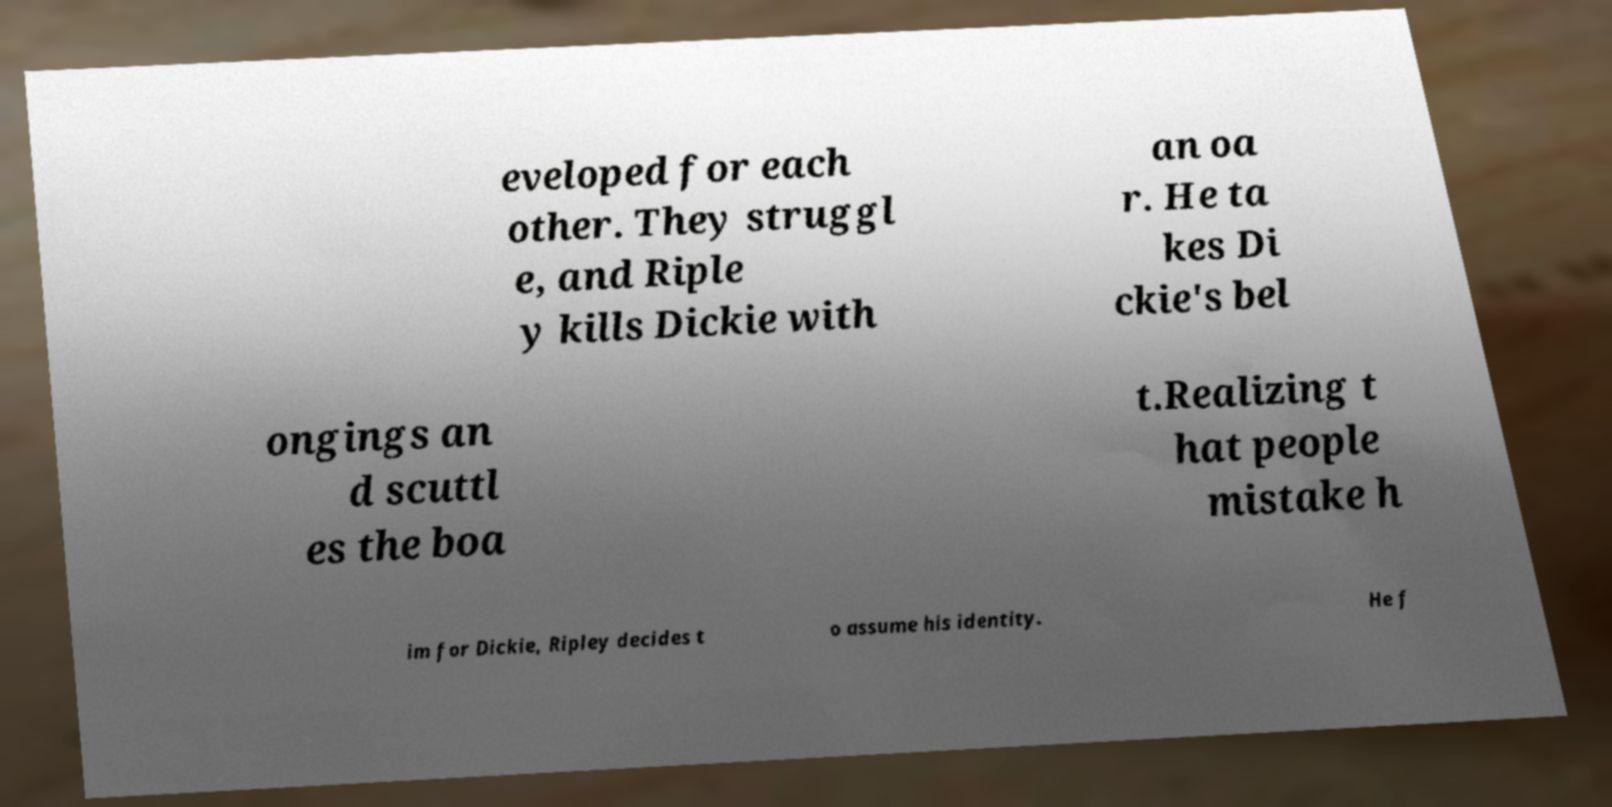What messages or text are displayed in this image? I need them in a readable, typed format. eveloped for each other. They struggl e, and Riple y kills Dickie with an oa r. He ta kes Di ckie's bel ongings an d scuttl es the boa t.Realizing t hat people mistake h im for Dickie, Ripley decides t o assume his identity. He f 